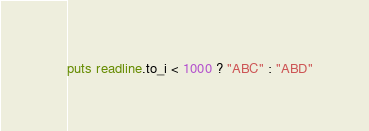Convert code to text. <code><loc_0><loc_0><loc_500><loc_500><_Ruby_>puts readline.to_i < 1000 ? "ABC" : "ABD"</code> 